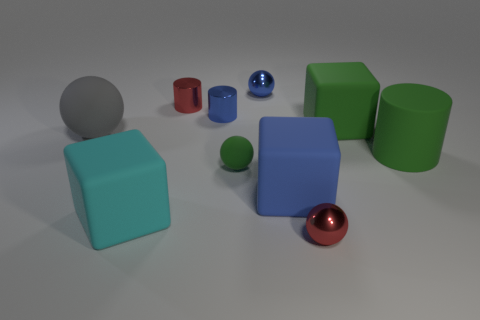Subtract all blue shiny balls. How many balls are left? 3 Subtract all green balls. How many balls are left? 3 Subtract 1 cylinders. How many cylinders are left? 2 Subtract all cylinders. How many objects are left? 7 Subtract all red blocks. Subtract all yellow cylinders. How many blocks are left? 3 Add 7 small red shiny objects. How many small red shiny objects exist? 9 Subtract 0 gray blocks. How many objects are left? 10 Subtract all gray shiny spheres. Subtract all green things. How many objects are left? 7 Add 3 large green matte objects. How many large green matte objects are left? 5 